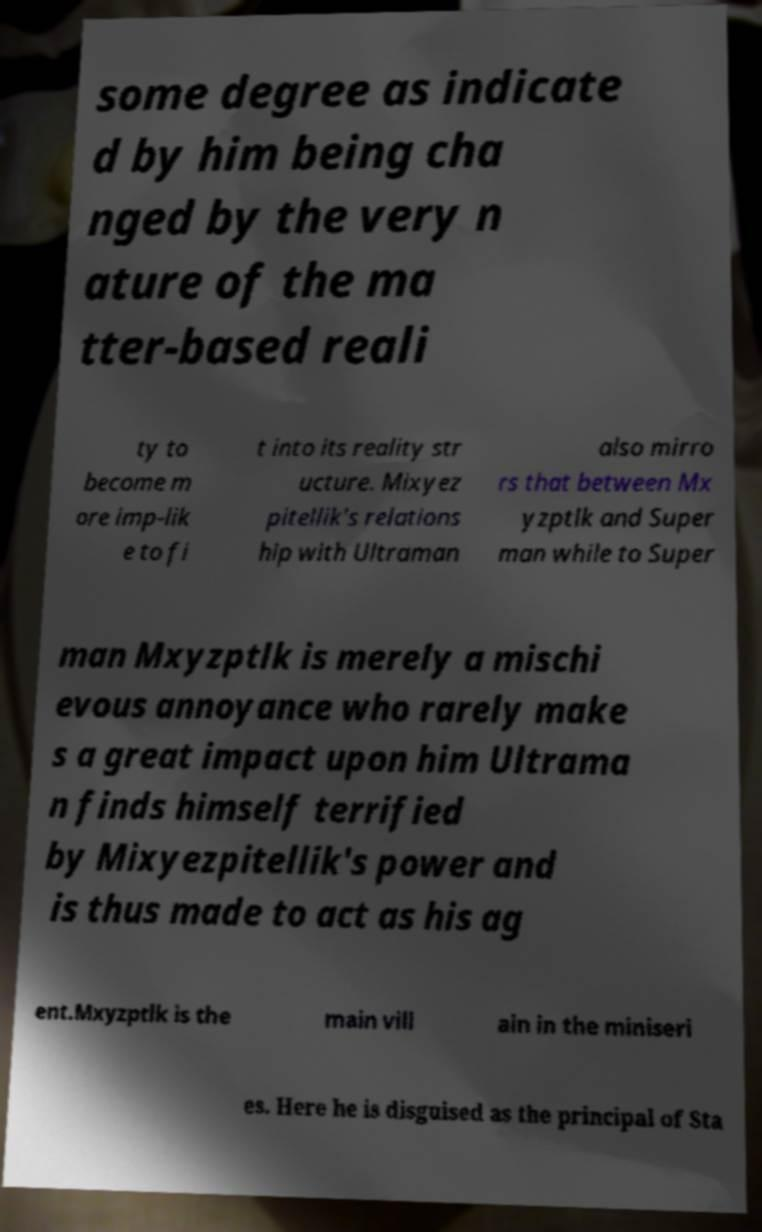I need the written content from this picture converted into text. Can you do that? some degree as indicate d by him being cha nged by the very n ature of the ma tter-based reali ty to become m ore imp-lik e to fi t into its reality str ucture. Mixyez pitellik's relations hip with Ultraman also mirro rs that between Mx yzptlk and Super man while to Super man Mxyzptlk is merely a mischi evous annoyance who rarely make s a great impact upon him Ultrama n finds himself terrified by Mixyezpitellik's power and is thus made to act as his ag ent.Mxyzptlk is the main vill ain in the miniseri es. Here he is disguised as the principal of Sta 